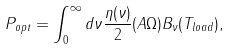<formula> <loc_0><loc_0><loc_500><loc_500>P _ { o p t } = \int _ { 0 } ^ { \infty } d \nu \frac { \eta ( \nu ) } { 2 } ( A \Omega ) B _ { \nu } ( T _ { l o a d } ) ,</formula> 